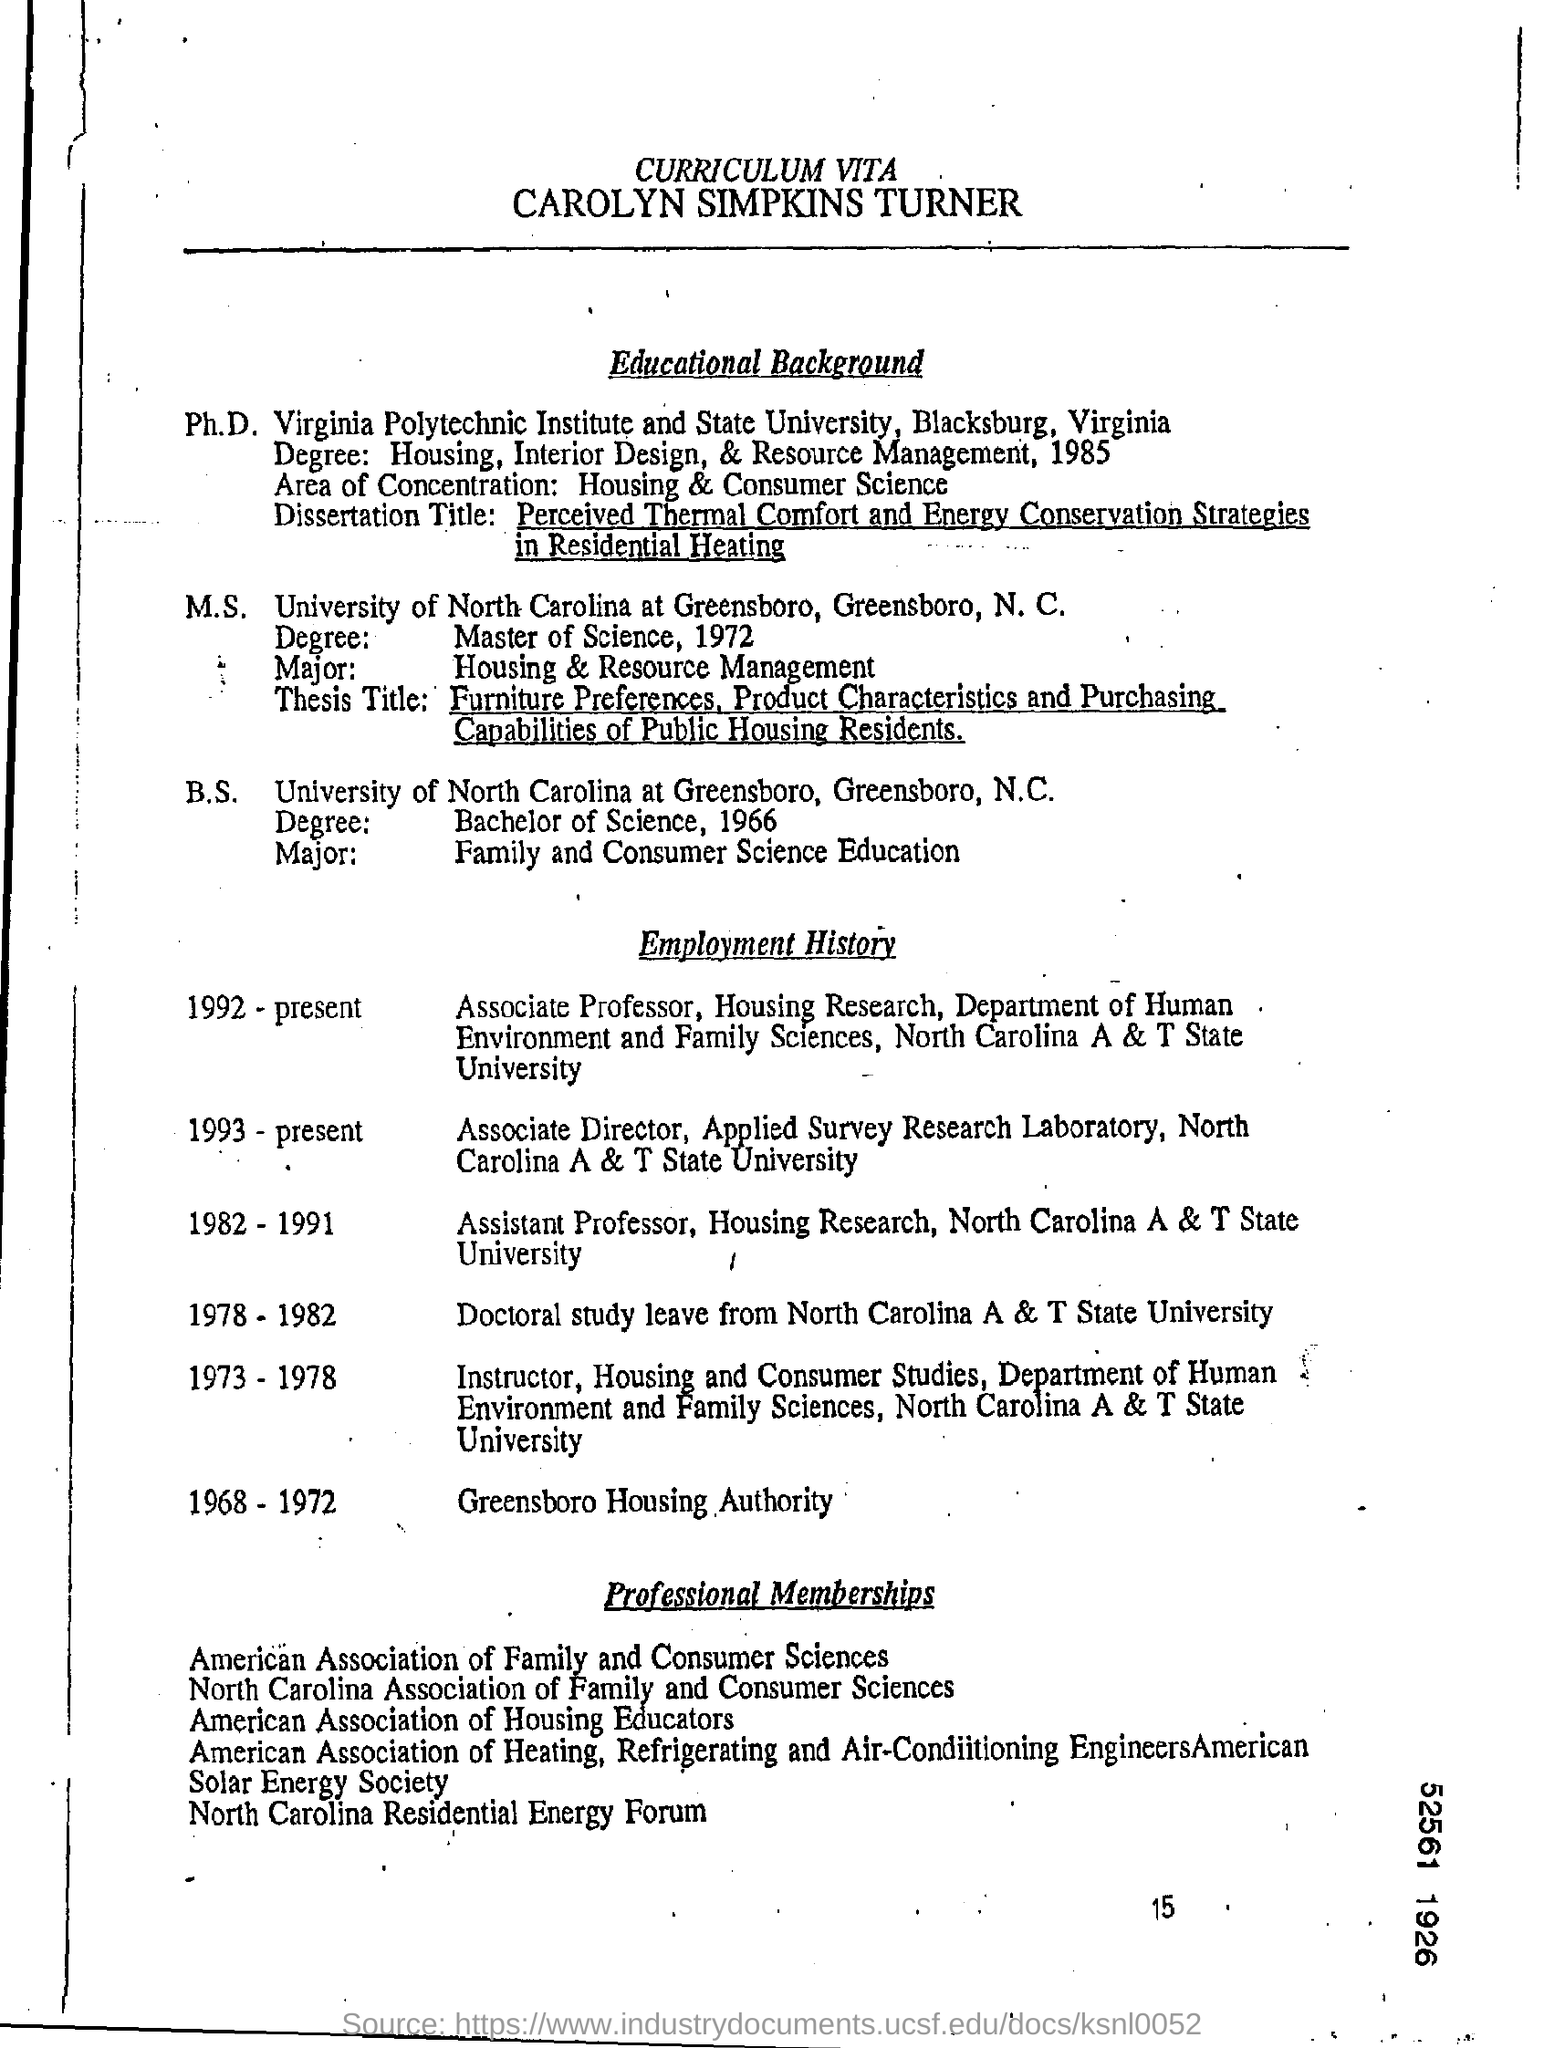List a handful of essential elements in this visual. The person whose curriculum vitae is Carolyn Simpkins Turner is... Carolyn took doctoral study leave in the year 1978-1982. Carolyn has held the job role of Associate Professor from 1952 to present. Carolyn graduated with a Master of Science degree from the University of North Carolina at Greensboro. 